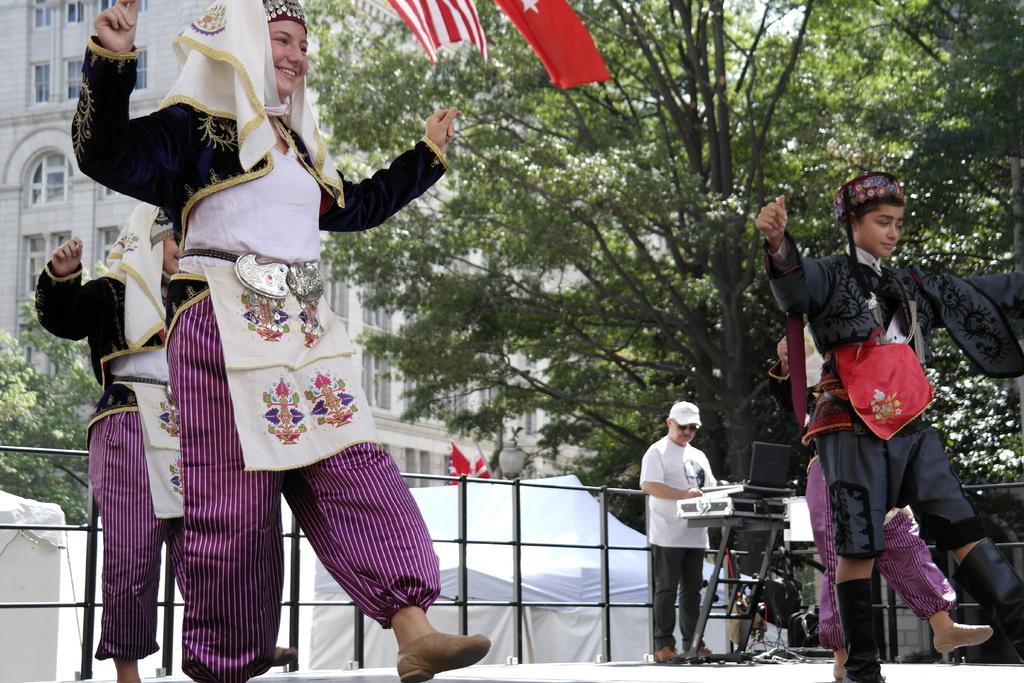Describe this image in one or two sentences. These four people are dancing. Far this person is standing. In-front of this person there is a table with objects. Background there are flags, fence, trees and buildings with windows. 